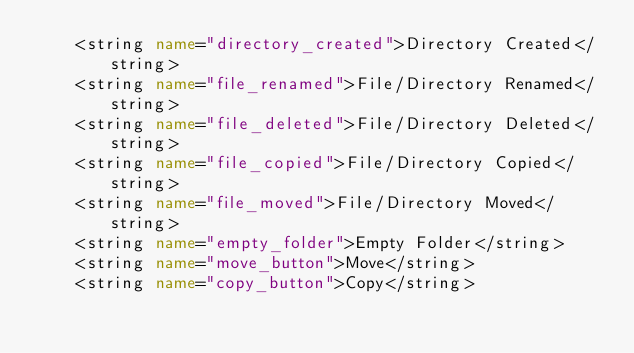Convert code to text. <code><loc_0><loc_0><loc_500><loc_500><_XML_>    <string name="directory_created">Directory Created</string>
    <string name="file_renamed">File/Directory Renamed</string>
    <string name="file_deleted">File/Directory Deleted</string>
    <string name="file_copied">File/Directory Copied</string>
    <string name="file_moved">File/Directory Moved</string>
    <string name="empty_folder">Empty Folder</string>
    <string name="move_button">Move</string>
    <string name="copy_button">Copy</string></code> 